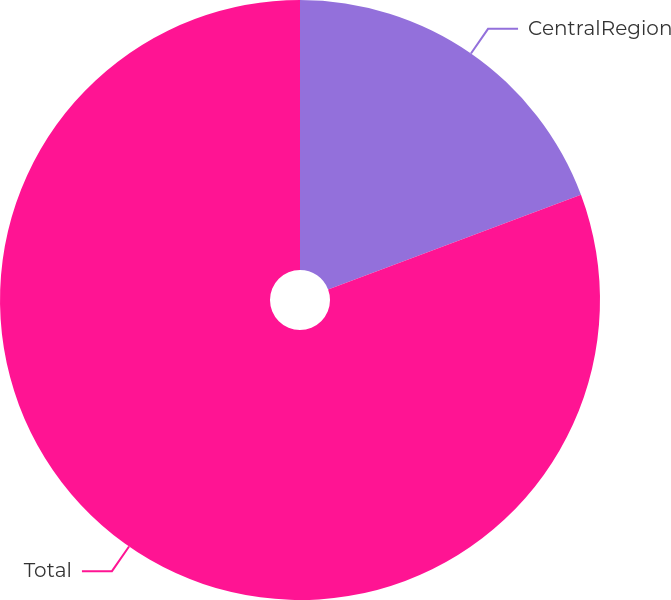Convert chart to OTSL. <chart><loc_0><loc_0><loc_500><loc_500><pie_chart><fcel>CentralRegion<fcel>Total<nl><fcel>19.3%<fcel>80.7%<nl></chart> 